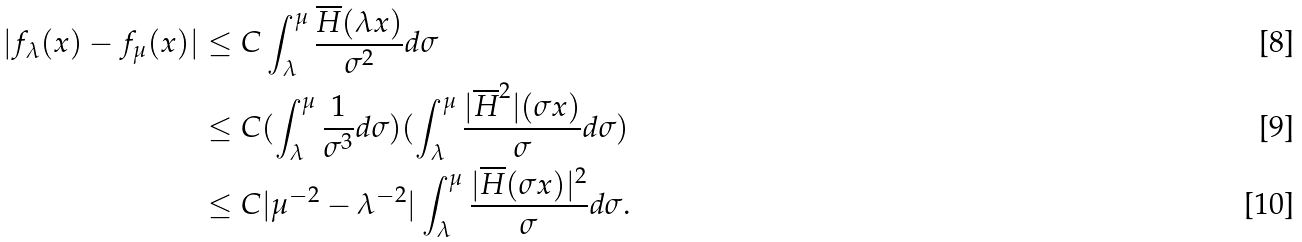<formula> <loc_0><loc_0><loc_500><loc_500>| f _ { \lambda } ( x ) - f _ { \mu } ( x ) | & \leq C \int ^ { \mu } _ { \lambda } \frac { \overline { H } ( \lambda x ) } { \sigma ^ { 2 } } d \sigma \\ & \leq C ( \int _ { \lambda } ^ { \mu } \frac { 1 } { \sigma ^ { 3 } } d \sigma ) ( \int _ { \lambda } ^ { \mu } \frac { | \overline { H } ^ { 2 } | ( \sigma x ) } { \sigma } d \sigma ) \\ & \leq C | \mu ^ { - 2 } - \lambda ^ { - 2 } | \int _ { \lambda } ^ { \mu } \frac { | \overline { H } ( \sigma x ) | ^ { 2 } } { \sigma } d \sigma .</formula> 